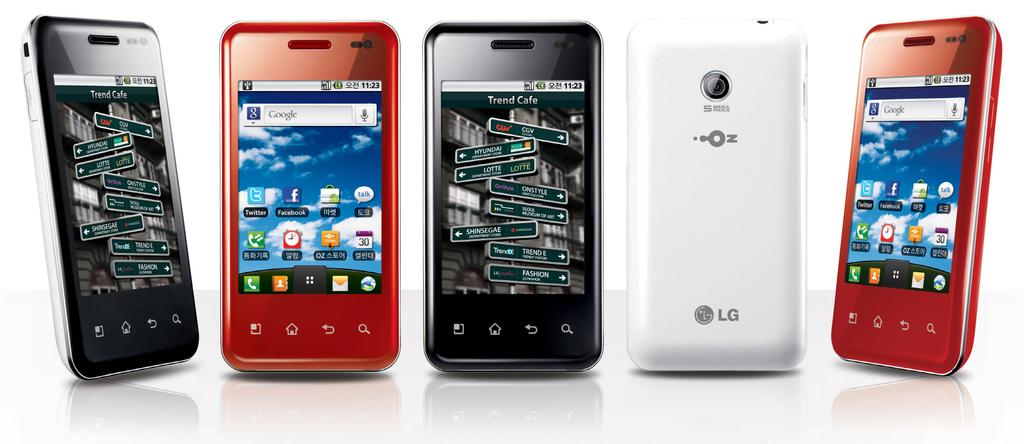<image>
Present a compact description of the photo's key features. Several red, black and white LG phones are next to each other 